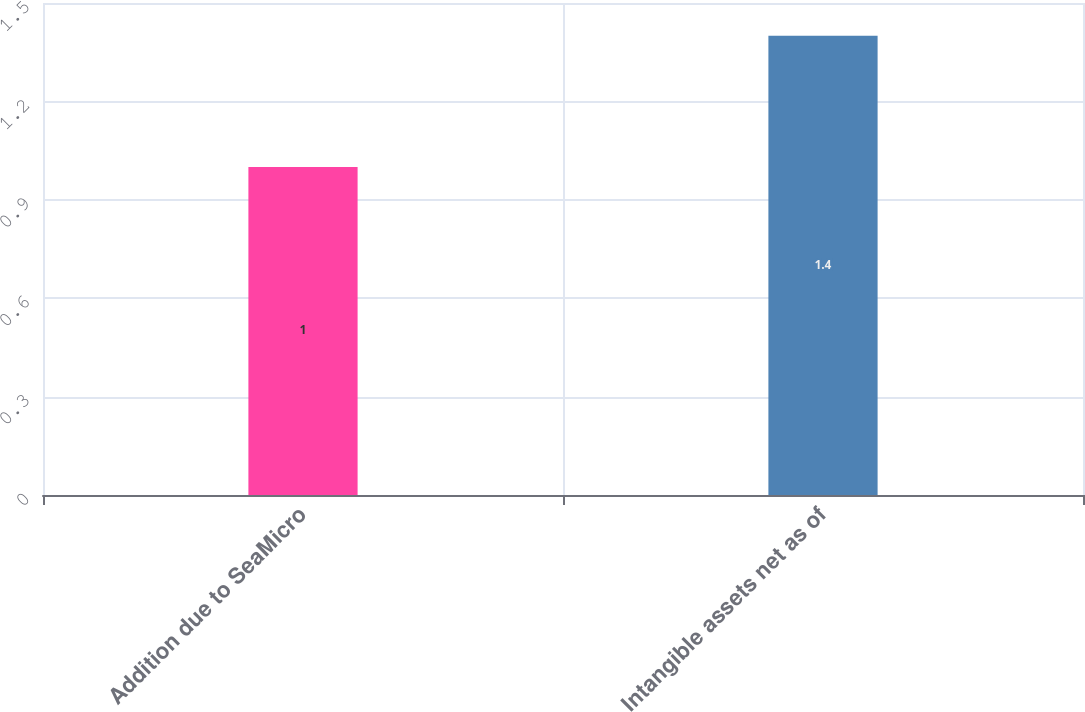<chart> <loc_0><loc_0><loc_500><loc_500><bar_chart><fcel>Addition due to SeaMicro<fcel>Intangible assets net as of<nl><fcel>1<fcel>1.4<nl></chart> 